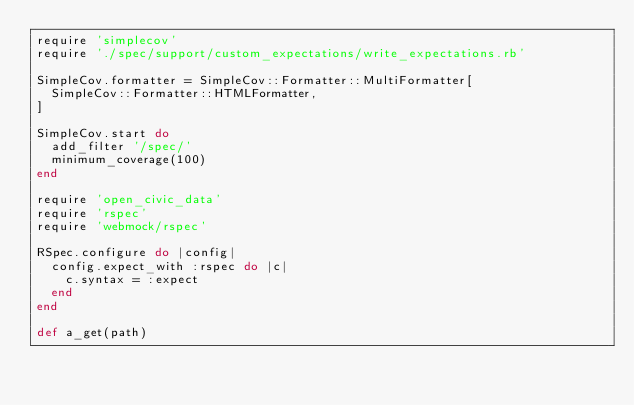Convert code to text. <code><loc_0><loc_0><loc_500><loc_500><_Ruby_>require 'simplecov'
require './spec/support/custom_expectations/write_expectations.rb'

SimpleCov.formatter = SimpleCov::Formatter::MultiFormatter[
  SimpleCov::Formatter::HTMLFormatter,
]

SimpleCov.start do
  add_filter '/spec/'
  minimum_coverage(100)
end

require 'open_civic_data'
require 'rspec'
require 'webmock/rspec'

RSpec.configure do |config|
  config.expect_with :rspec do |c|
    c.syntax = :expect
  end
end

def a_get(path)</code> 